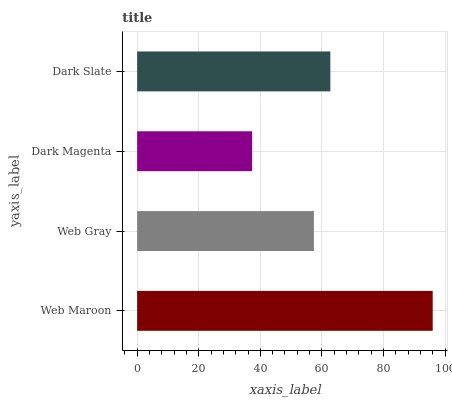Is Dark Magenta the minimum?
Answer yes or no. Yes. Is Web Maroon the maximum?
Answer yes or no. Yes. Is Web Gray the minimum?
Answer yes or no. No. Is Web Gray the maximum?
Answer yes or no. No. Is Web Maroon greater than Web Gray?
Answer yes or no. Yes. Is Web Gray less than Web Maroon?
Answer yes or no. Yes. Is Web Gray greater than Web Maroon?
Answer yes or no. No. Is Web Maroon less than Web Gray?
Answer yes or no. No. Is Dark Slate the high median?
Answer yes or no. Yes. Is Web Gray the low median?
Answer yes or no. Yes. Is Dark Magenta the high median?
Answer yes or no. No. Is Dark Magenta the low median?
Answer yes or no. No. 